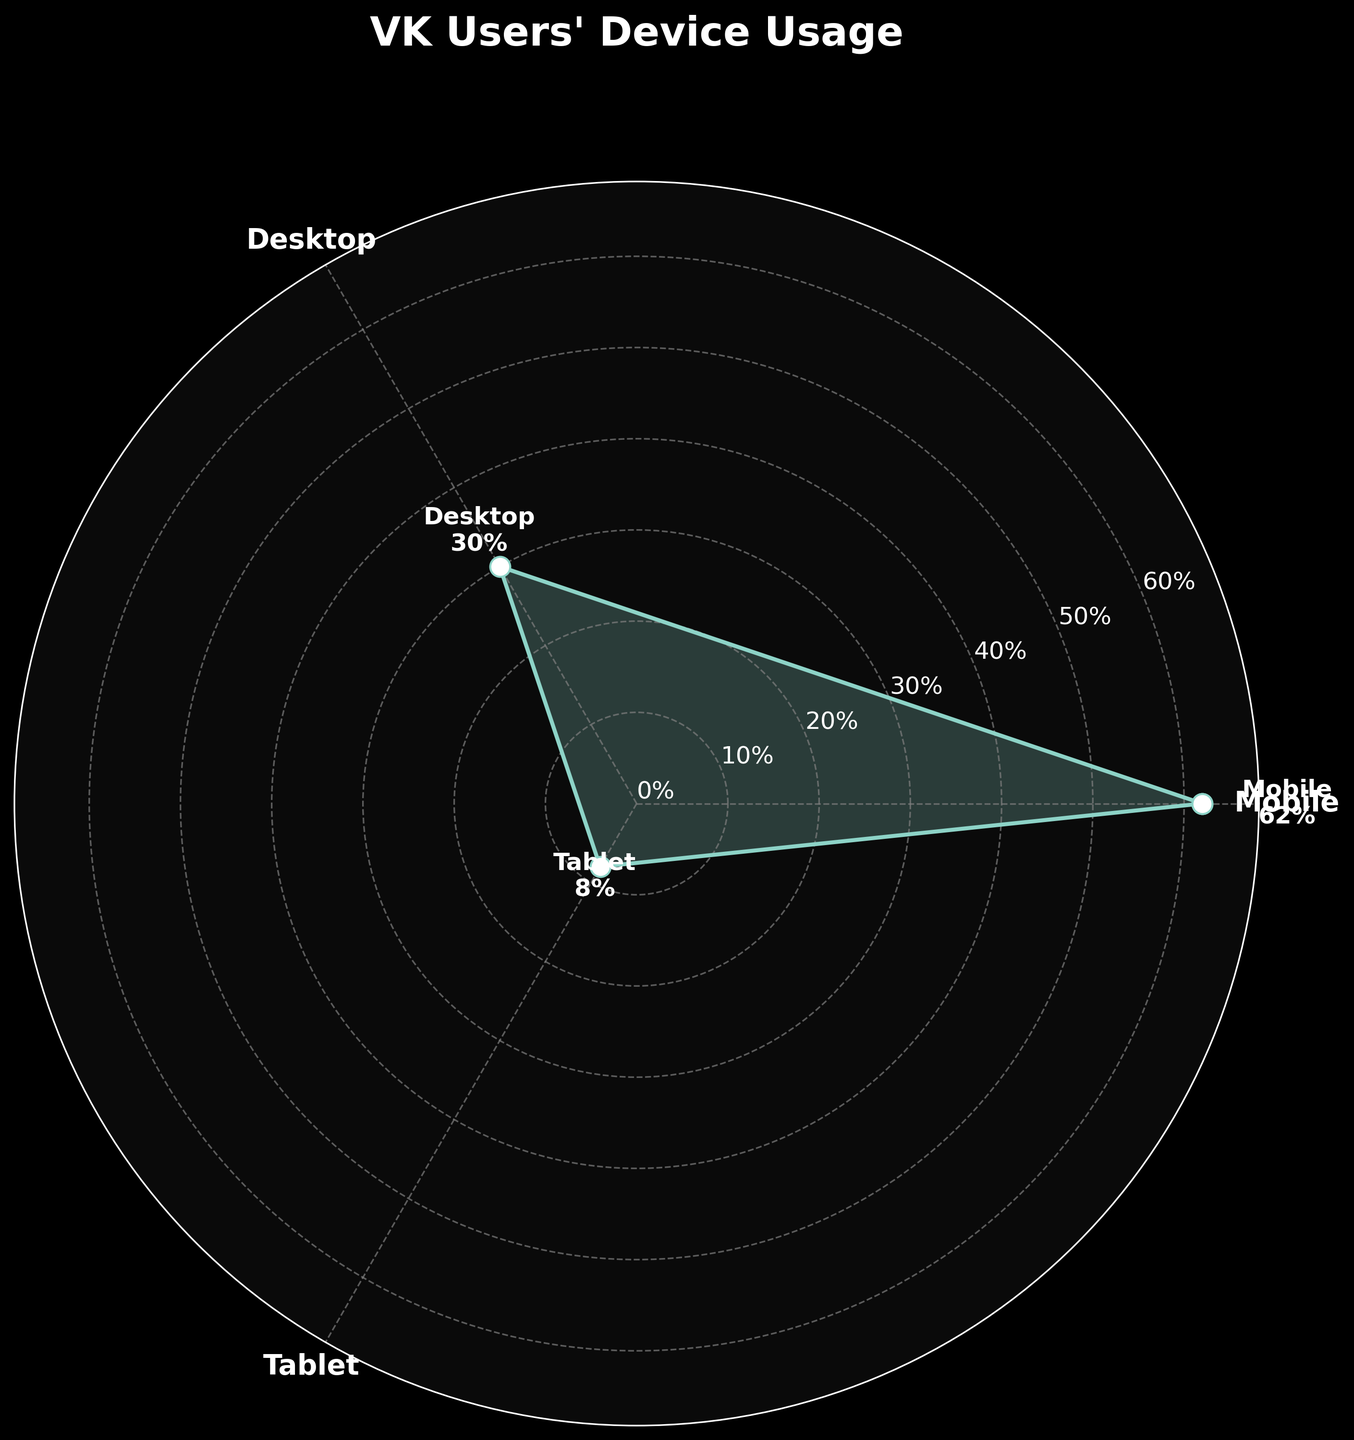What is the title of the figure? The title is the text displayed at the top of the figure that summarizes the main content. In the polar area chart, the title is clearly labeled at the top.
Answer: "VK Users' Device Usage" Which device has the highest usage percentage, and what is that percentage? To find the device with the highest usage percentage, look at the radial extremes of the plot. The label closest to the outermost ring represents the highest value.
Answer: Mobile, 62% What is the difference in usage percentage between Desktop and Tablet? Find the values for Desktop and Tablet. The Desktop usage is 30% and the Tablet usage is 8%. Subtract the smaller value from the larger one: 30 - 8.
Answer: 22% How many device categories are displayed in the chart? Locate and count the distinct categories with labels positioned around the polar axis.
Answer: 3 What is the sum of the usage percentages for Desktop and Tablet? Add the given usage percentages of Desktop (30%) and Tablet (8%): 30 + 8.
Answer: 38% Is the usage percentage of Mobile more than twice the usage percentage of Desktop? Compare the Mobile percentage (62%) to twice the Desktop percentage (2 * 30% = 60%). Since 62% > 60%, the statement is true.
Answer: Yes What is the average usage percentage across all devices? Find the sum of the percentages of all devices and divide by the total number of devices: (62 + 30 + 8) / 3.
Answer: 33.33% Which device category is represented with the smallest area in the chart, and what is its percentage? Identify the category label closest to the center, which represents the smallest area.
Answer: Tablet, 8% Is the difference between the highest and lowest usage percentages greater than 50%? Calculate the difference between Mobile (62%) and Tablet (8%): 62 - 8 = 54%. Compare it to 50%.
Answer: Yes What color scheme is used as the background for the chart? The chart features a distinctive dark theme, as indicated by the styling and dark colors.
Answer: Dark background 